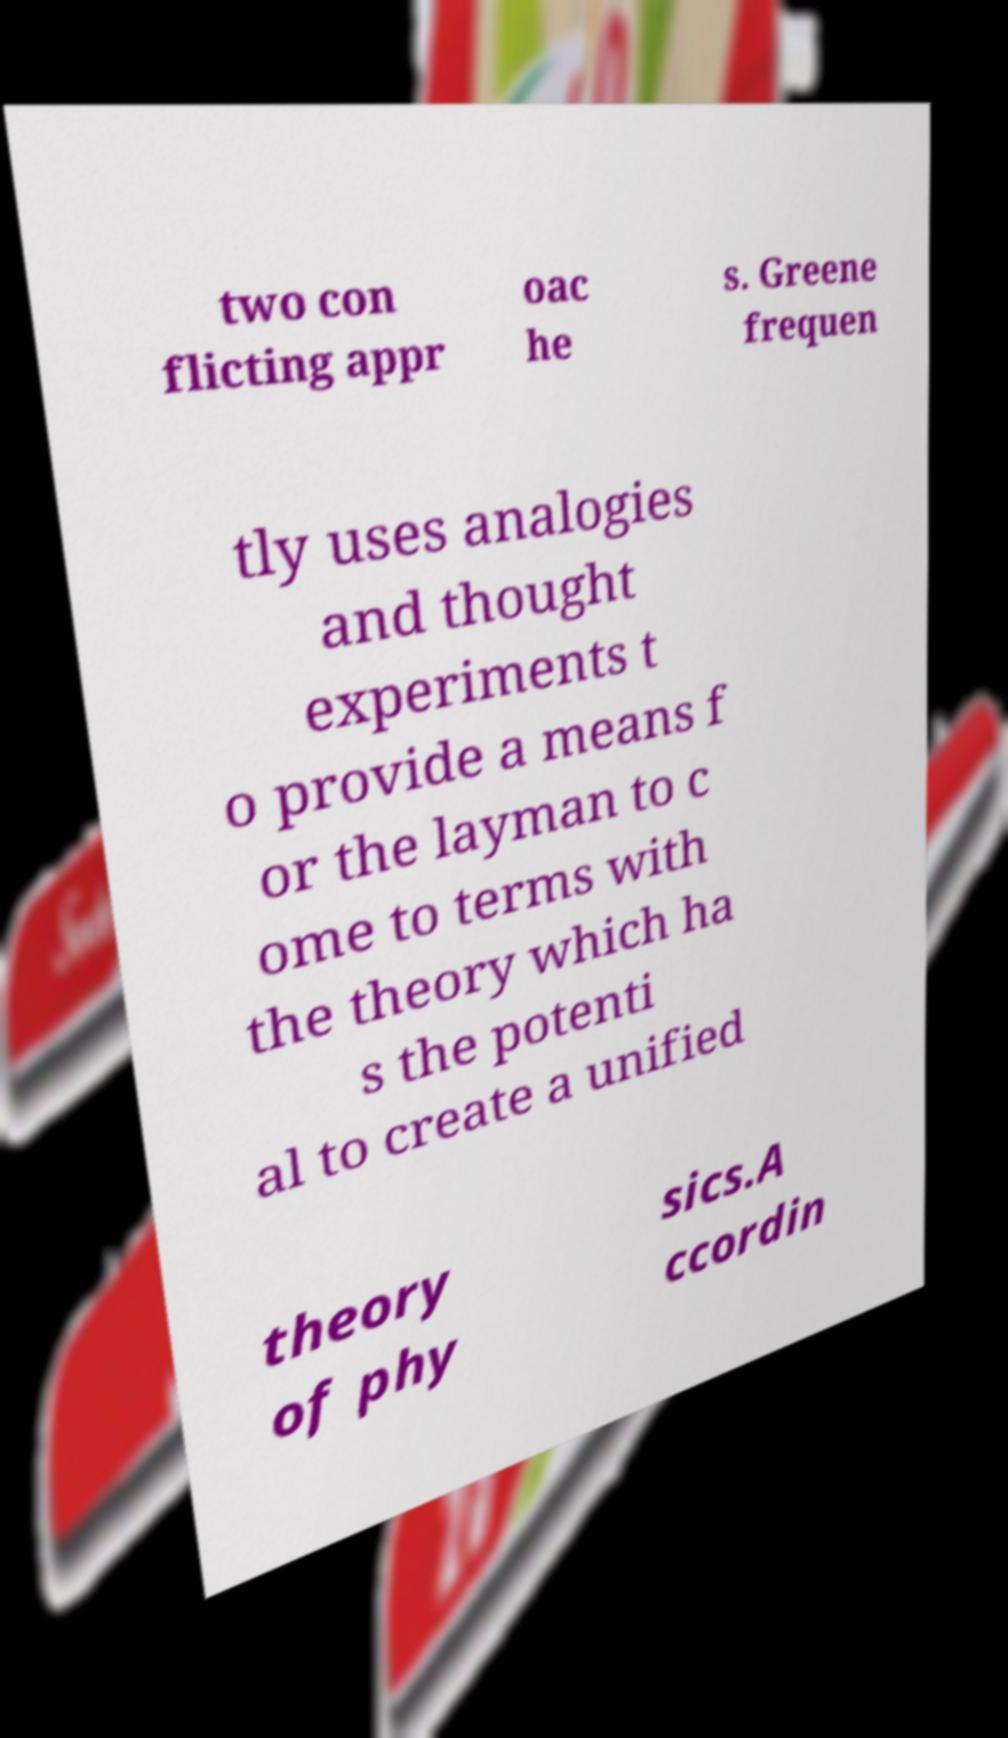Can you accurately transcribe the text from the provided image for me? two con flicting appr oac he s. Greene frequen tly uses analogies and thought experiments t o provide a means f or the layman to c ome to terms with the theory which ha s the potenti al to create a unified theory of phy sics.A ccordin 